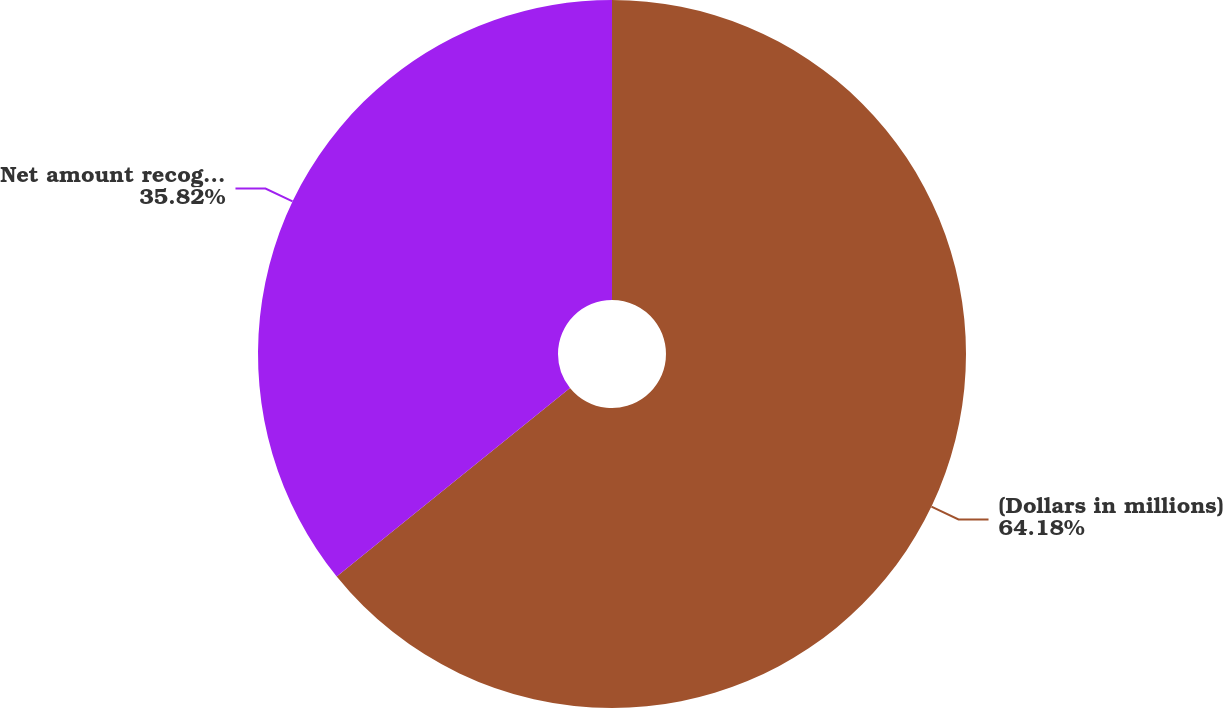Convert chart to OTSL. <chart><loc_0><loc_0><loc_500><loc_500><pie_chart><fcel>(Dollars in millions)<fcel>Net amount recognized at<nl><fcel>64.18%<fcel>35.82%<nl></chart> 